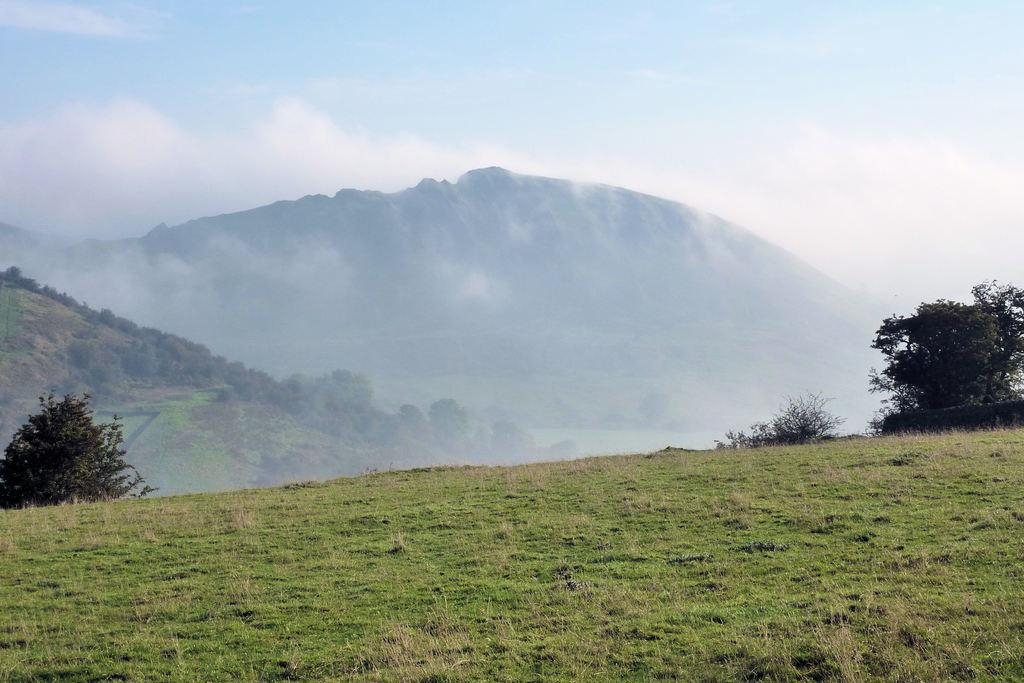Where was the picture taken? The picture was clicked outside. What can be seen in the foreground of the image? There is green grass in the foreground. What elements are present in the center of the image? There are plants and rocks in the center of the image. What is visible in the background of the image? The sky is visible in the background, and there is fog present. How many snakes are slithering through the grass in the image? There are no snakes visible in the image; it features green grass in the foreground. What type of cloud can be seen in the background of the image? There is no specific cloud mentioned in the image; it only states that there is fog in the background. 